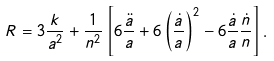Convert formula to latex. <formula><loc_0><loc_0><loc_500><loc_500>R = 3 \frac { k } { a ^ { 2 } } + \frac { 1 } { n ^ { 2 } } \left [ 6 \frac { \ddot { a } } { a } + 6 \left ( \frac { \dot { a } } { a } \right ) ^ { 2 } - 6 \frac { \dot { a } } { a } \frac { \dot { n } } { n } \right ] .</formula> 